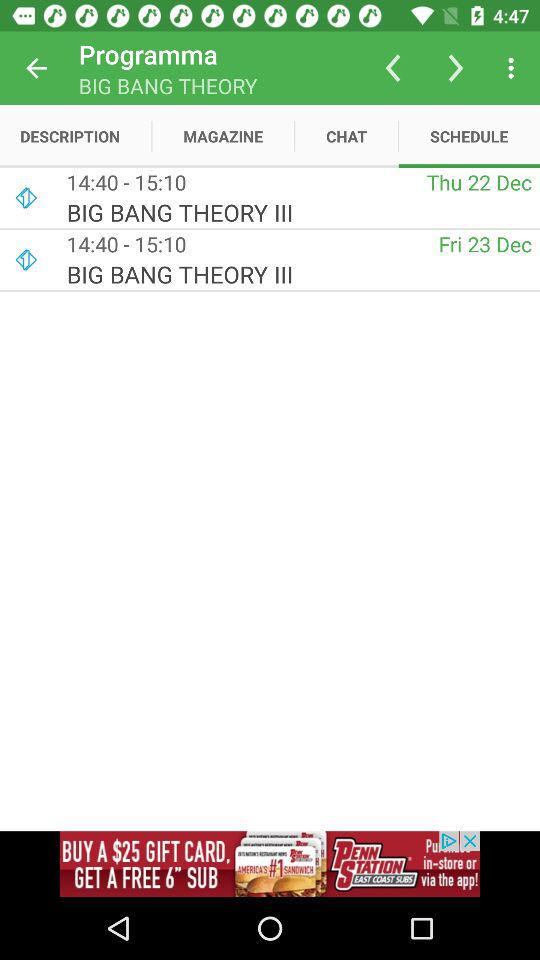Which tab has selected? The selected tab is "SCHEDULE". 